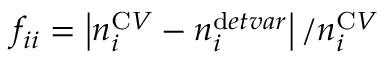<formula> <loc_0><loc_0><loc_500><loc_500>f _ { i i } = \left | n _ { i } ^ { C V } - n _ { i } ^ { d e t v a r } \right | / n _ { i } ^ { C V }</formula> 